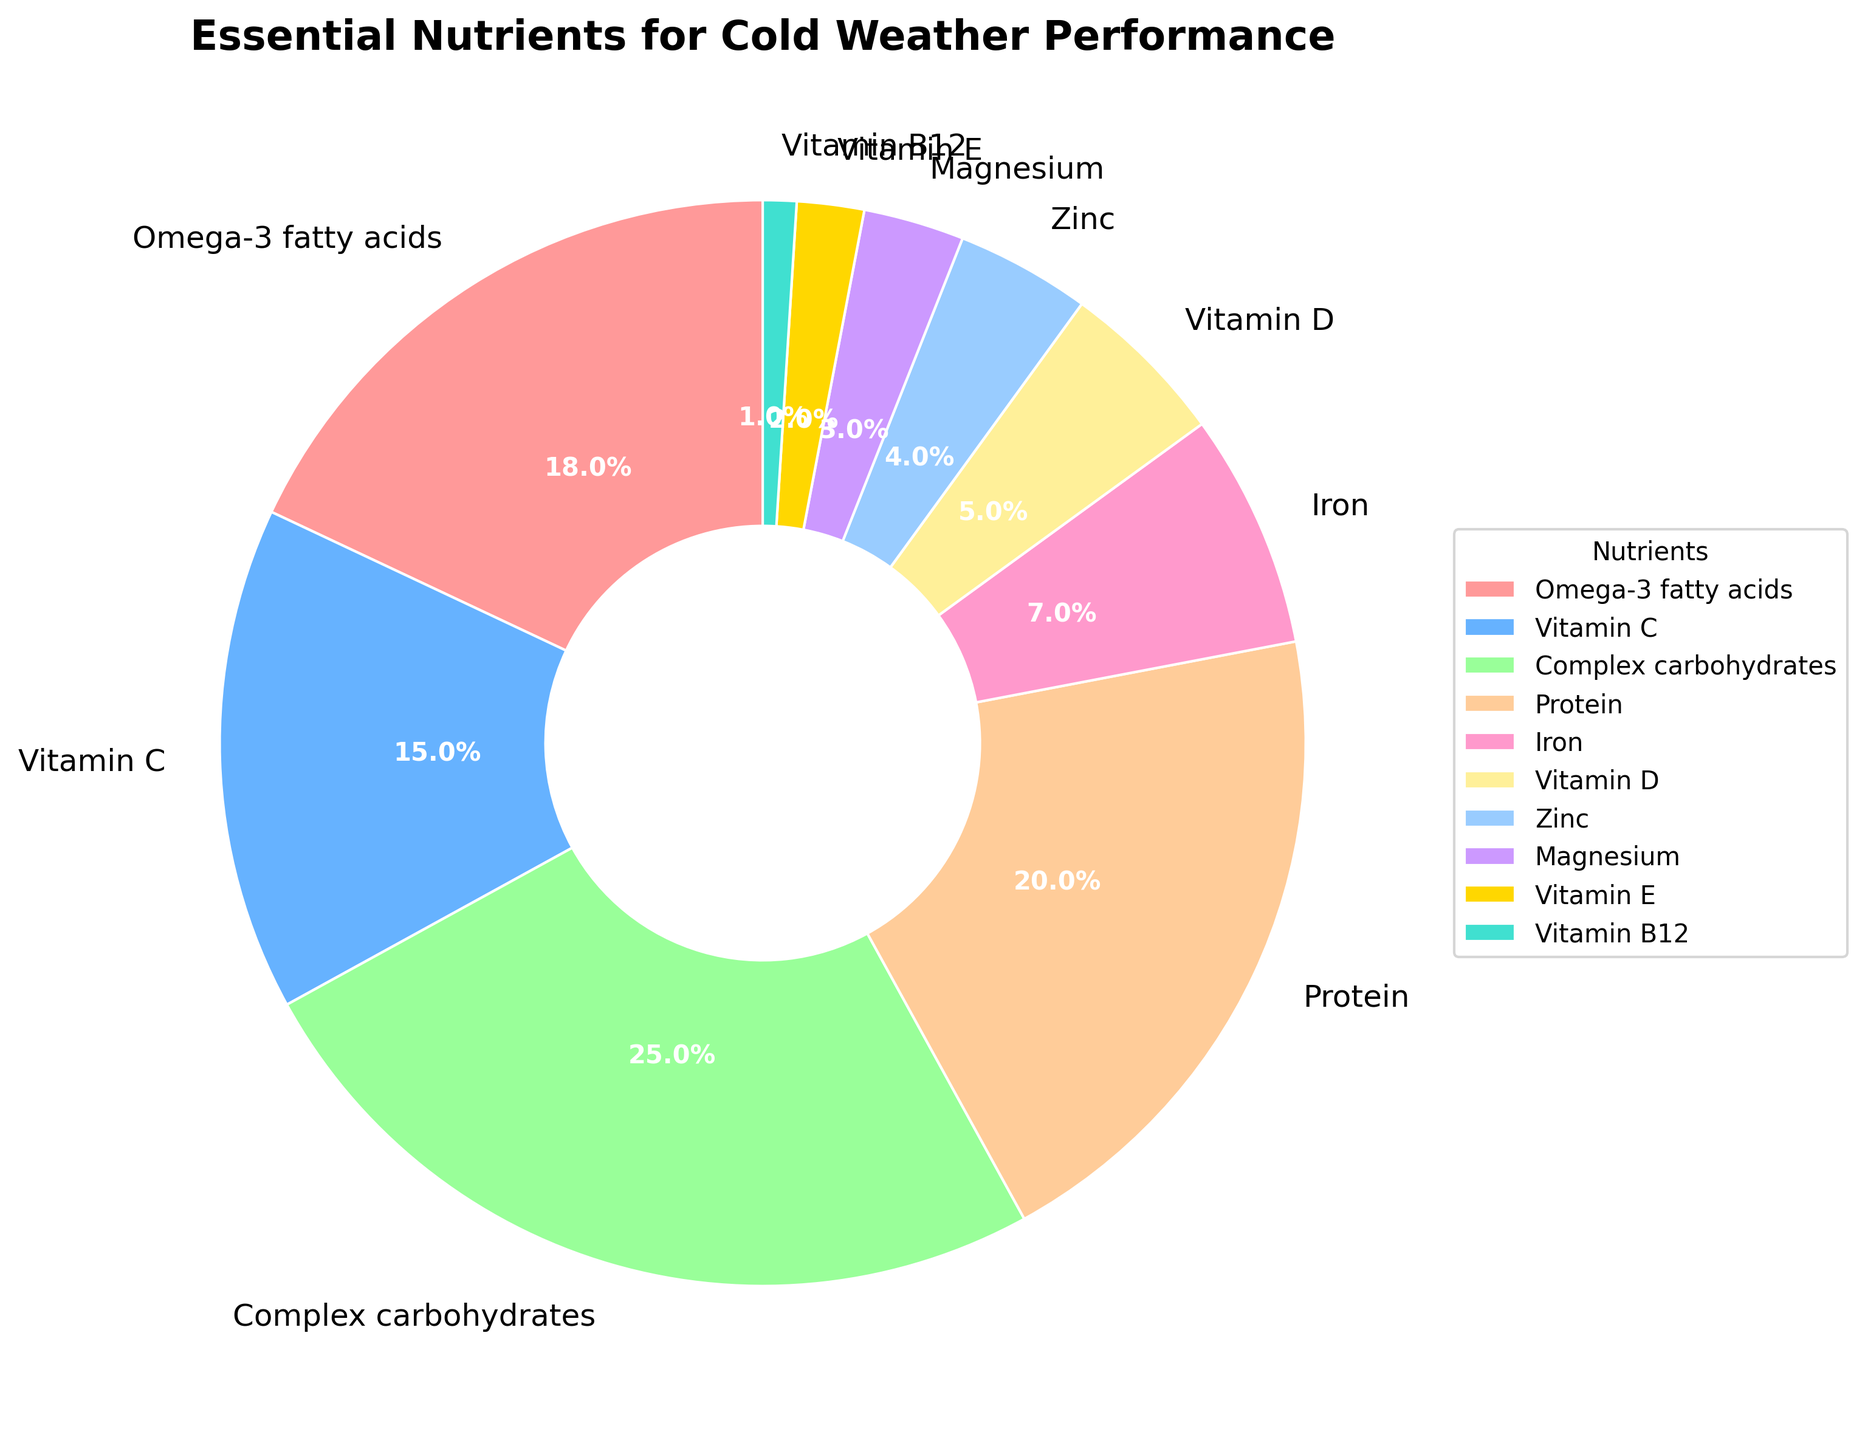What nutrient has the highest percentage? The nutrient with the highest percentage is the one with the largest section in the pie chart, labeled with the highest percentage. In this case, it's "Complex carbohydrates" with 25%.
Answer: Complex carbohydrates Which nutrient has a higher percentage, Protein or Iron? Compare the sections of the pie chart labeled "Protein" and "Iron". Protein has 20% and Iron has 7%, so Protein has a higher percentage.
Answer: Protein What's the total percentage of Omega-3 fatty acids and Vitamin E? To find the total percentage, add the percentages of "Omega-3 fatty acids" (18%) and "Vitamin E" (2%). 18 + 2 = 20%.
Answer: 20% Which nutrients are represented by segments smaller than 5% of the pie chart? Look for the segments with percentages less than 5% in the pie chart. These are labeled as "Iron" (7%), "Vitamin D" (5%), "Zinc" (4%), "Magnesium" (3%), "Vitamin E" (2%), and "Vitamin B12" (1%). Out of these, "Zinc", "Magnesium", "Vitamin E", and "Vitamin B12" are all less than 5%.
Answer: Zinc, Magnesium, Vitamin E, Vitamin B12 Can you list the nutrients in descending order of their percentages? Arrange the nutrients from the largest to the smallest percentage: Complex carbohydrates (25%), Protein (20%), Omega-3 fatty acids (18%), Vitamin C (15%), Iron (7%), Vitamin D (5%), Zinc (4%), Magnesium (3%), Vitamin E (2%), Vitamin B12 (1%).
Answer: Complex carbohydrates, Protein, Omega-3 fatty acids, Vitamin C, Iron, Vitamin D, Zinc, Magnesium, Vitamin E, Vitamin B12 If you combine the percentages of all vitamins (Vitamin C, Vitamin D, Vitamin E, Vitamin B12), what is the total? Sum the percentages of all vitamins: Vitamin C (15%), Vitamin D (5%), Vitamin E (2%), and Vitamin B12 (1%). 15 + 5 + 2 + 1 = 23%.
Answer: 23% What is the difference in percentage between Complex carbohydrates and Omega-3 fatty acids? Subtract the smaller percentage (Omega-3 fatty acids, 18%) from the larger percentage (Complex carbohydrates, 25%). 25 - 18 = 7%.
Answer: 7% Which two nutrients together make up more than 40% of the pie chart? Check combinations of nutrients to find pairs that together exceed 40%. Complex carbohydrates (25%) and Protein (20%) together amount to 45%, which is more than 40%.
Answer: Complex carbohydrates and Protein What percentage of the pie chart is comprised of minerals (Iron, Zinc, Magnesium)? Add the percentages of the minerals: Iron (7%), Zinc (4%), and Magnesium (3%). 7 + 4 + 3 = 14%.
Answer: 14% What is the smallest nutrient segment, and what is its percentage? Identify the smallest segment in the pie chart, which is "Vitamin B12" with 1%.
Answer: Vitamin B12, 1% 